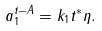Convert formula to latex. <formula><loc_0><loc_0><loc_500><loc_500>a _ { 1 } ^ { t - A } = k _ { 1 } t ^ { \ast } \eta .</formula> 